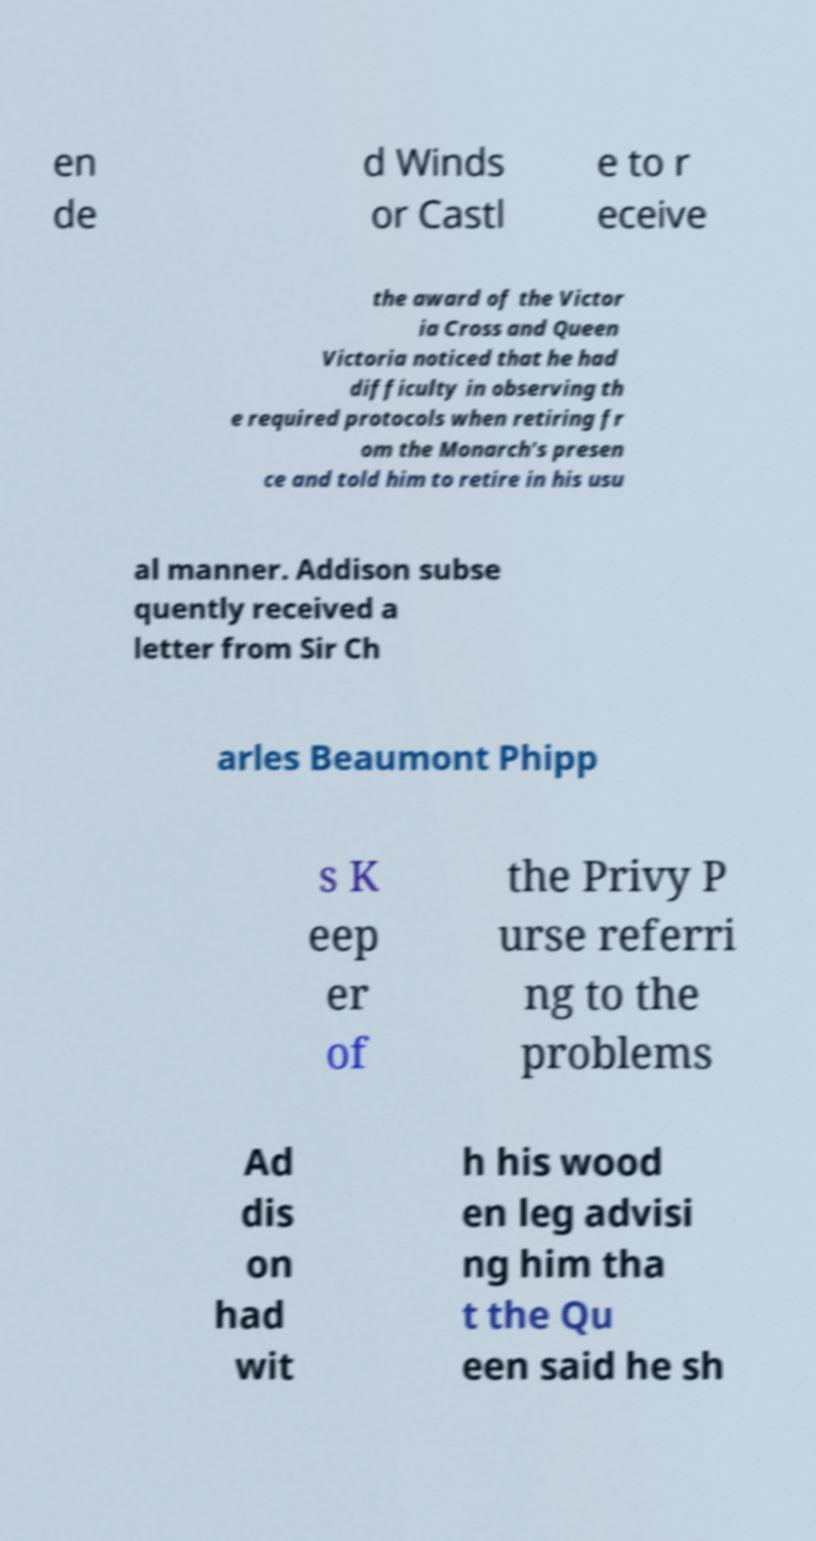Could you extract and type out the text from this image? en de d Winds or Castl e to r eceive the award of the Victor ia Cross and Queen Victoria noticed that he had difficulty in observing th e required protocols when retiring fr om the Monarch's presen ce and told him to retire in his usu al manner. Addison subse quently received a letter from Sir Ch arles Beaumont Phipp s K eep er of the Privy P urse referri ng to the problems Ad dis on had wit h his wood en leg advisi ng him tha t the Qu een said he sh 